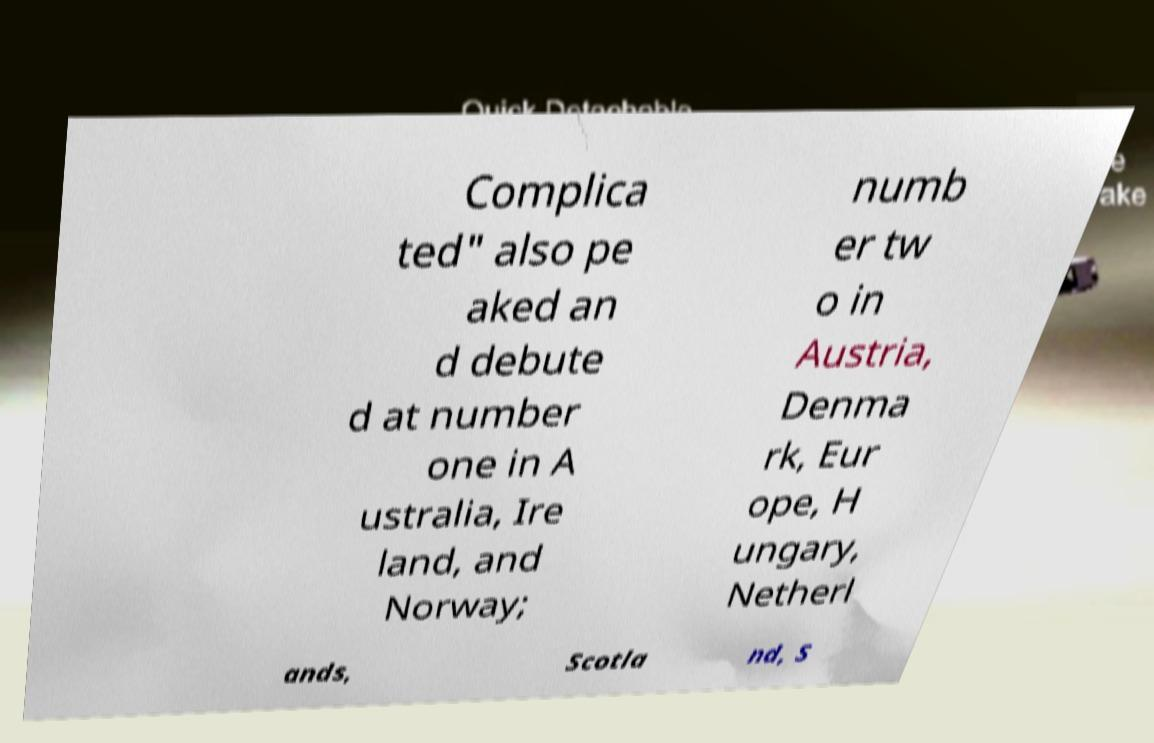Could you assist in decoding the text presented in this image and type it out clearly? Complica ted" also pe aked an d debute d at number one in A ustralia, Ire land, and Norway; numb er tw o in Austria, Denma rk, Eur ope, H ungary, Netherl ands, Scotla nd, S 